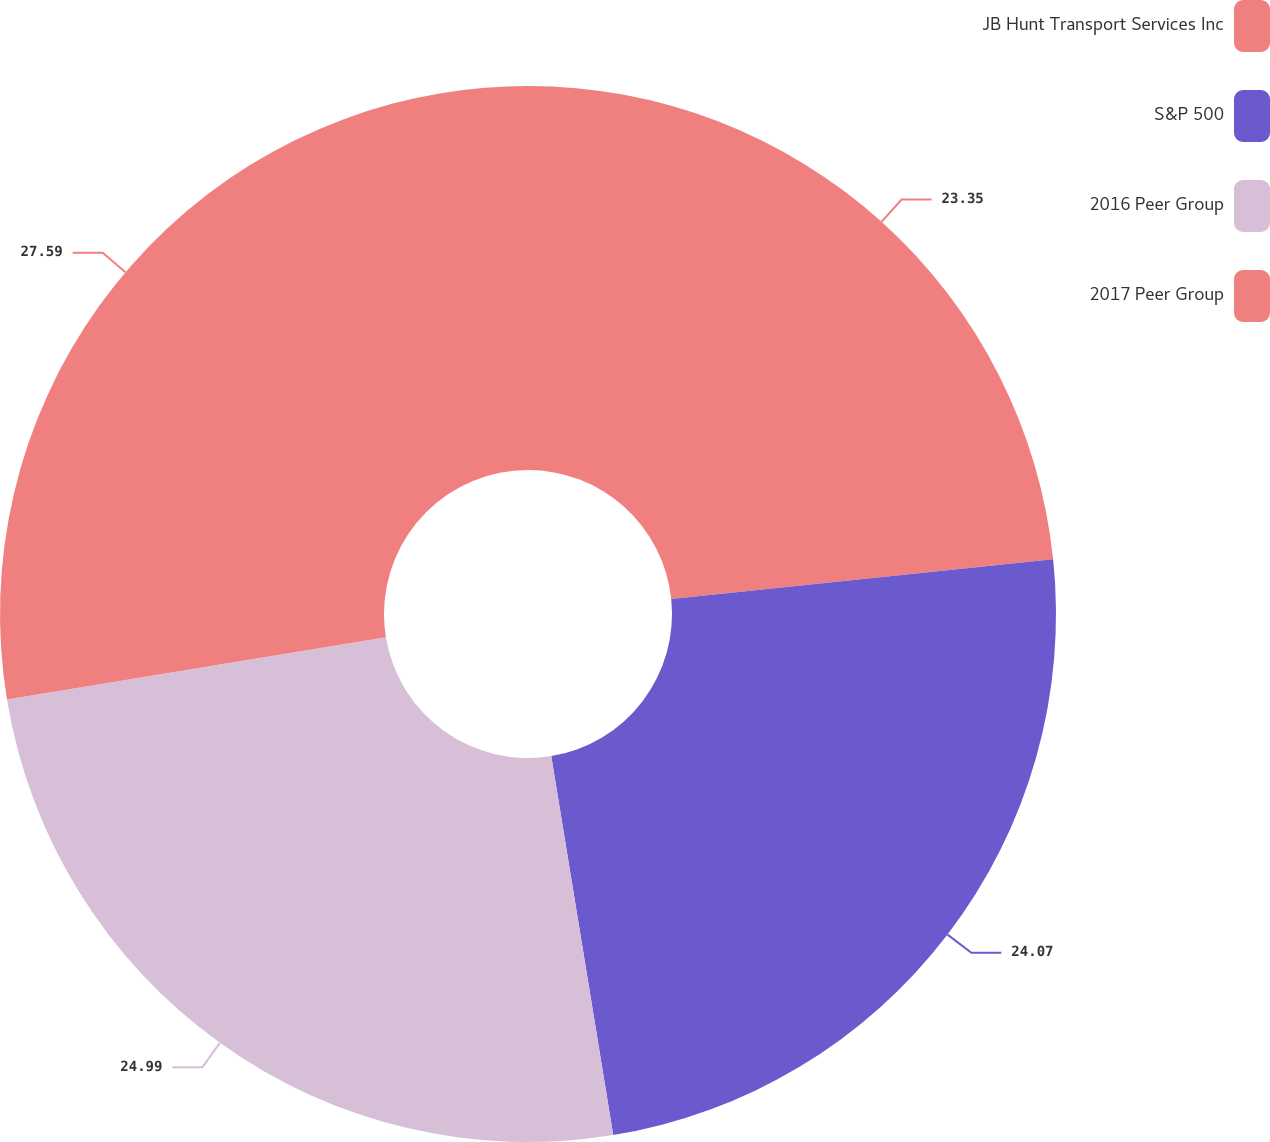Convert chart to OTSL. <chart><loc_0><loc_0><loc_500><loc_500><pie_chart><fcel>JB Hunt Transport Services Inc<fcel>S&P 500<fcel>2016 Peer Group<fcel>2017 Peer Group<nl><fcel>23.35%<fcel>24.07%<fcel>24.99%<fcel>27.59%<nl></chart> 